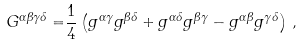Convert formula to latex. <formula><loc_0><loc_0><loc_500><loc_500>G ^ { \alpha \beta \gamma \delta } = & \frac { 1 } { 4 } \left ( g ^ { \alpha \gamma } g ^ { \beta \delta } + g ^ { \alpha \delta } g ^ { \beta \gamma } - g ^ { \alpha \beta } g ^ { \gamma \delta } \right ) \, ,</formula> 